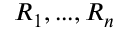<formula> <loc_0><loc_0><loc_500><loc_500>R _ { 1 } , \dots , R _ { n }</formula> 